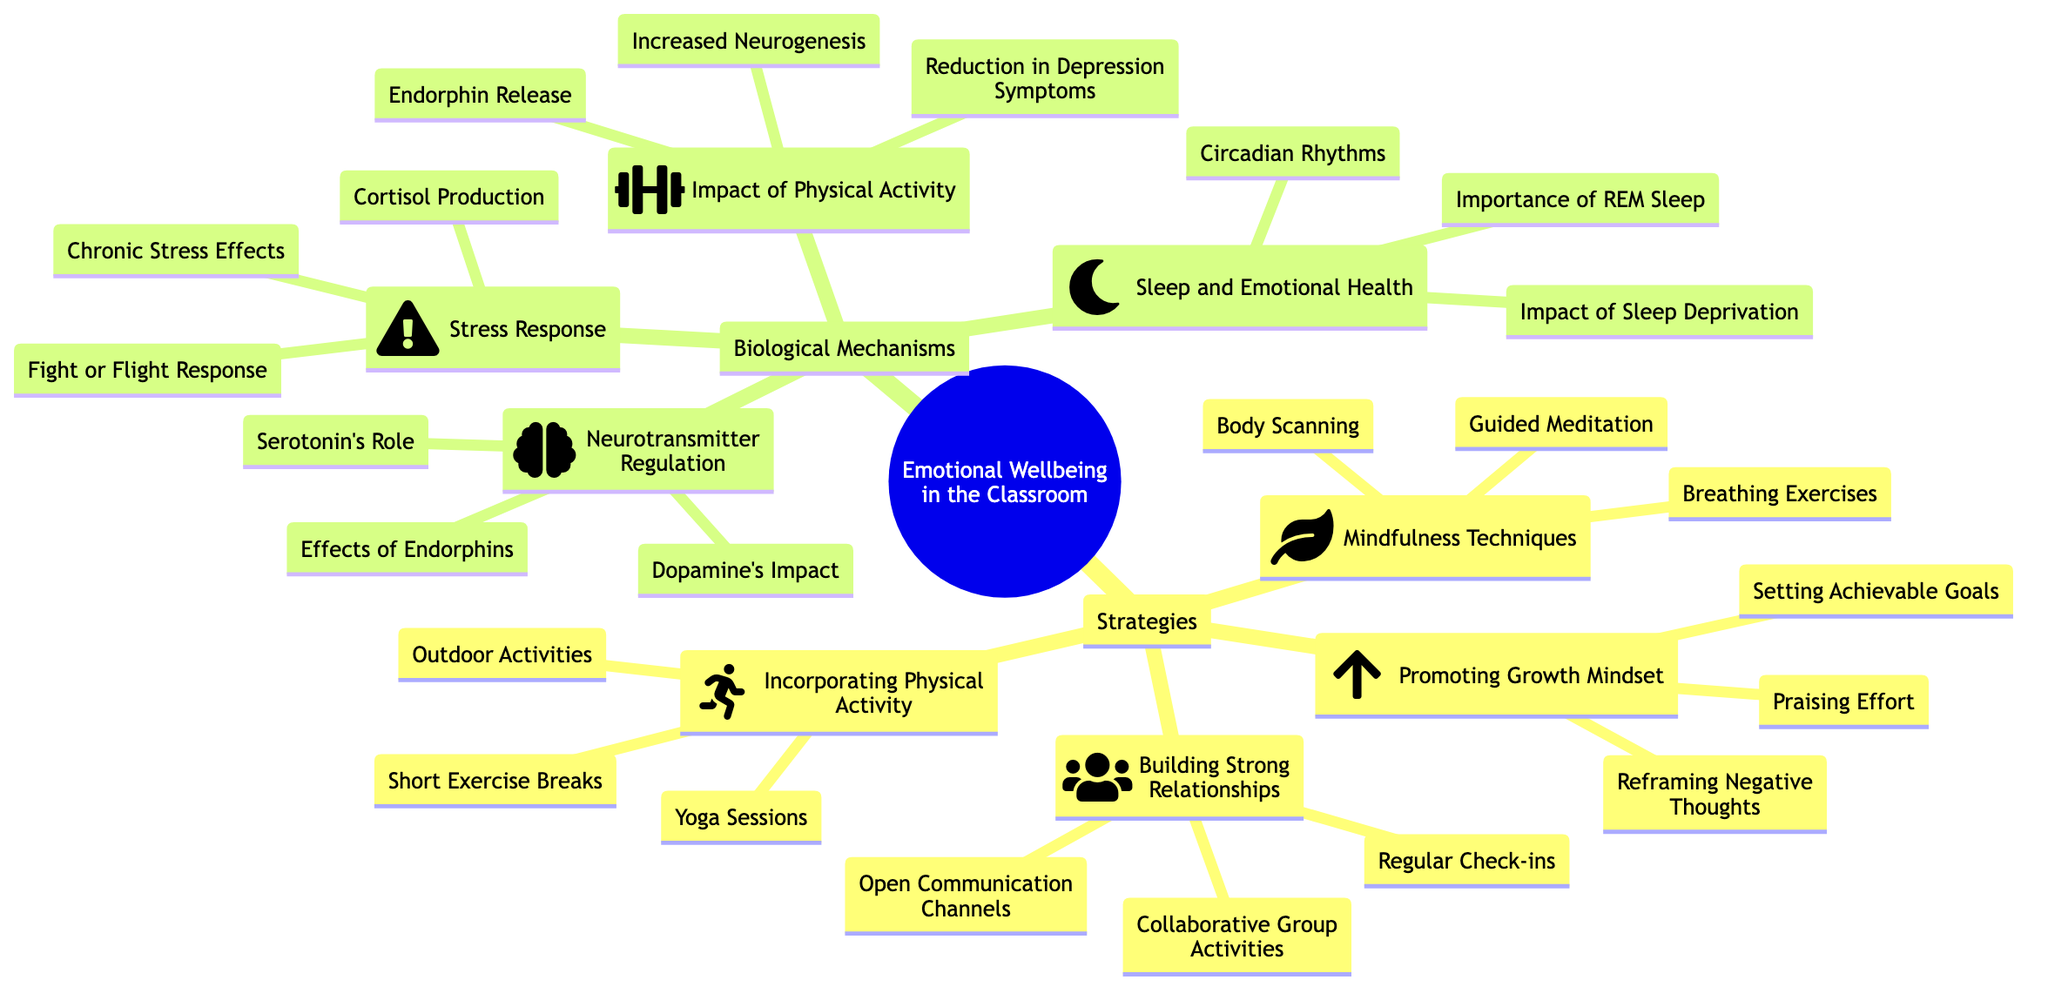What are the four main strategies listed for emotional wellbeing? The diagram lists four main strategies under "Strategies": Mindfulness Techniques, Promoting Growth Mindset, Building Strong Relationships, and Incorporating Physical Activity.
Answer: Mindfulness Techniques, Promoting Growth Mindset, Building Strong Relationships, Incorporating Physical Activity How many examples are provided for "Building Strong Relationships"? Under the "Building Strong Relationships" node, there are three examples: Regular Check-ins, Collaborative Group Activities, and Open Communication Channels. Therefore, the total count is three.
Answer: 3 What is the description of "Mindfulness Techniques"? The description under "Mindfulness Techniques" states: "Encouraging students to practice mindfulness to reduce stress and enhance emotional regulation." This provides clarity on the purpose of this strategy.
Answer: Encouraging students to practice mindfulness to reduce stress and enhance emotional regulation Which biological mechanism involves the role of serotonin? The "Neurotransmitter Regulation" biological mechanism discusses the role of serotonin as it pertains to mood regulation. This highlights the importance of neurotransmitters in emotional health.
Answer: Neurotransmitter Regulation What are the key aspects mentioned under "Impact of Physical Activity"? The key aspects listed are: Increased Neurogenesis, Endorphin Release, and Reduction in Symptoms of Depression. These are crucial points on how physical activity affects emotional health.
Answer: Increased Neurogenesis, Endorphin Release, Reduction in Symptoms of Depression How does the diagram categorize the main topics? The main topics are categorized into two main branches: Strategies and Biological Mechanisms. These branches encompass various sub-nodes that provide strategies and biological insights for emotional wellbeing in the classroom.
Answer: Strategies and Biological Mechanisms What examples are provided for "Incorporating Physical Activity"? The examples given under "Incorporating Physical Activity" are Short Exercise Breaks, Yoga Sessions, and Outdoor Activities. This indicates various approaches to integrating physical movement into the classroom.
Answer: Short Exercise Breaks, Yoga Sessions, Outdoor Activities What is a key aspect of the "Stress Response"? One of the key aspects listed under "Stress Response" is Cortisol Production, which refers to the physiological stress response and its implications for emotional wellbeing.
Answer: Cortisol Production How many total strategies are outlined in the diagram? The diagram outlines four total strategies related to emotional wellbeing in the classroom, as seen in the "Strategies" node. This indicates a structured approach to fostering emotional health.
Answer: 4 